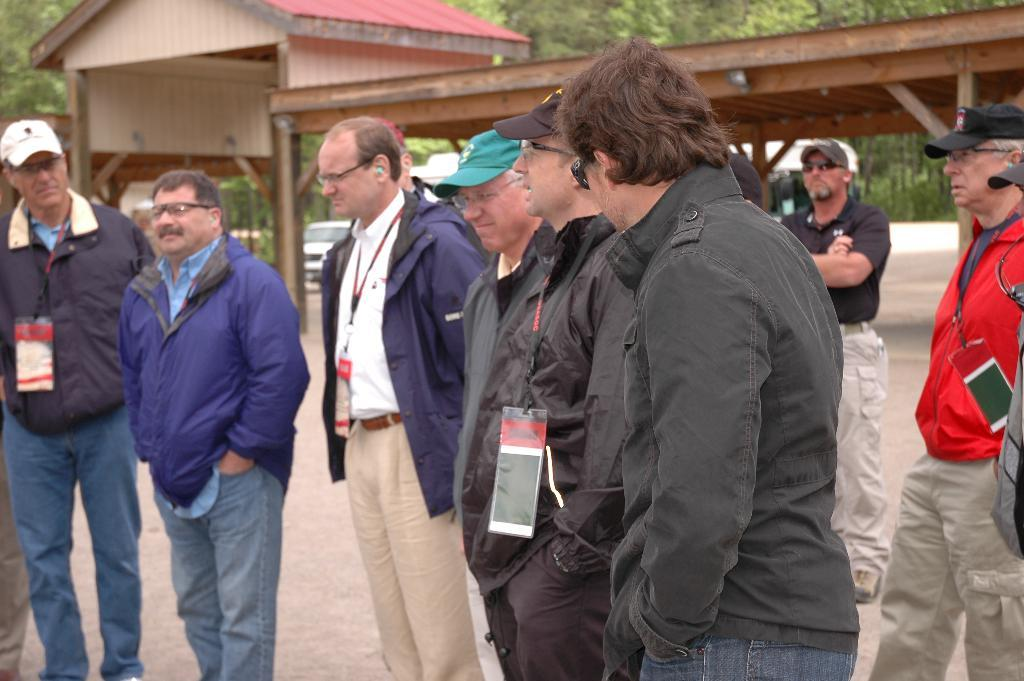How many people are in the group in the image? There is a group of people in the image, but the exact number is not specified. What are some people in the group doing? Some people in the group are standing. What can be seen on some of the people's clothing? Some people in the group are wearing badges. What can be seen in the background of the image? There is a shed, a car, and trees in the background of the image. What is the plot of the story being told by the people in the image? There is no story being told in the image, as it is a static photograph. What feeling is being expressed by the people in the image? The image does not convey any specific emotions or feelings; it simply shows a group of people and their actions. 